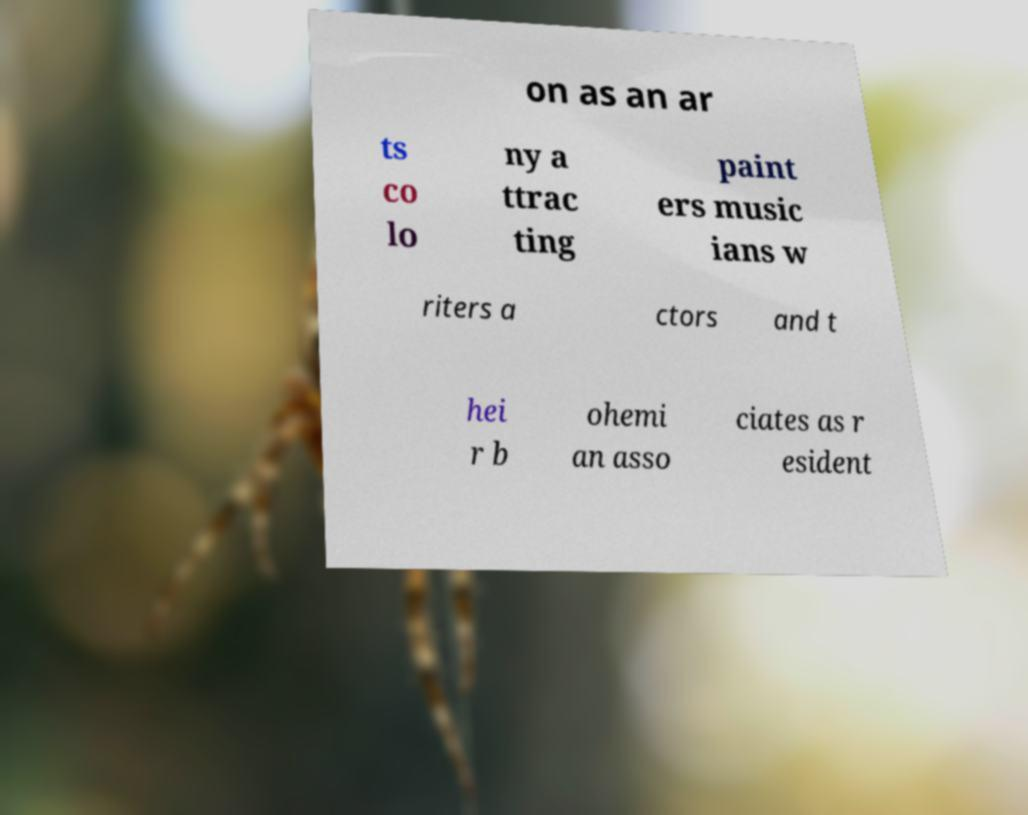Can you accurately transcribe the text from the provided image for me? on as an ar ts co lo ny a ttrac ting paint ers music ians w riters a ctors and t hei r b ohemi an asso ciates as r esident 